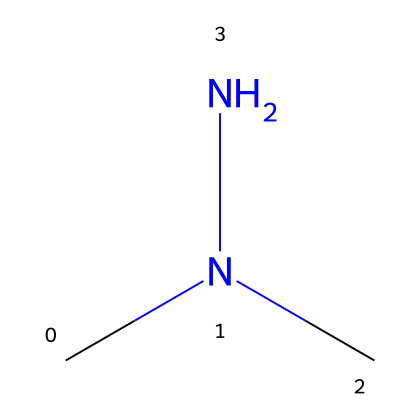How many nitrogen atoms are in 1,2-dimethylhydrazine? The SMILES representation shows two "N" letters, which represent nitrogen atoms in the structure. Therefore, the total number of nitrogen atoms in 1,2-dimethylhydrazine is two.
Answer: 2 What is the total number of carbon atoms in 1,2-dimethylhydrazine? The "C" in the SMILES notation indicates carbon atoms. There are two "C" letters, so there are two carbon atoms in the molecule.
Answer: 2 Which functional group is present in 1,2-dimethylhydrazine? The presence of the nitrogen atoms bonded to carbon indicates that this compound contains an amine functional group, specifically a hydrazine group due to the two nitrogen atoms.
Answer: amine What is the hybridization of the nitrogen atoms in 1,2-dimethylhydrazine? The nitrogen atoms in the structure are bonded to three substituents (two hydrogens and one carbon), specifically showing sp3 hybridization due to the presence of one lone pair and three bonds.
Answer: sp3 Is 1,2-dimethylhydrazine a potential carcinogen? 1,2-dimethylhydrazine is classified as a potential carcinogen, as studies have shown that its exposure can lead to carcinogenic effects in humans and animals.
Answer: yes What type of chemical is 1,2-dimethylhydrazine? 1,2-dimethylhydrazine falls under the class of compounds known as hydrazines, which are characterized by the presence of a hydrazine functional group.
Answer: hydrazine 